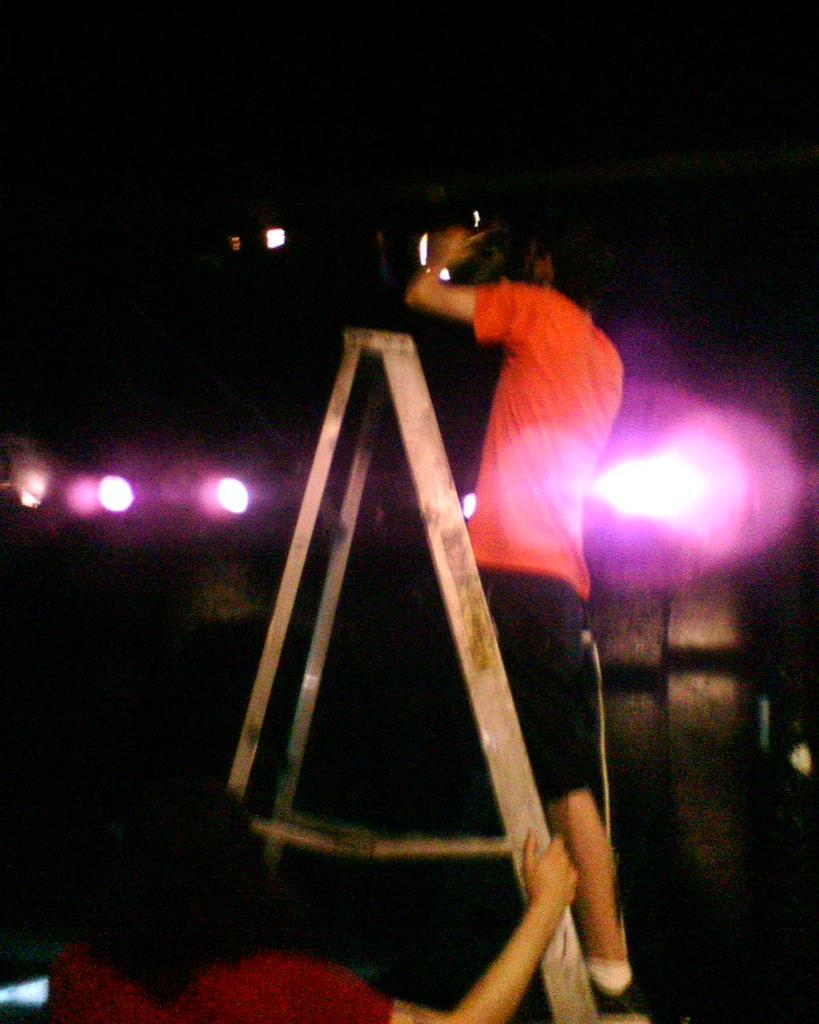What is the person in the image holding? The person is holding a tripod stand in the image. What is the other person in the image doing? The other person is standing and holding a camera on the tripod stand. Can you describe the background of the image? The background of the image is blurred. What type of nut is being cracked by the person holding the tripod stand in the image? There is no nut present in the image, and the person holding the tripod stand is not cracking a nut. 